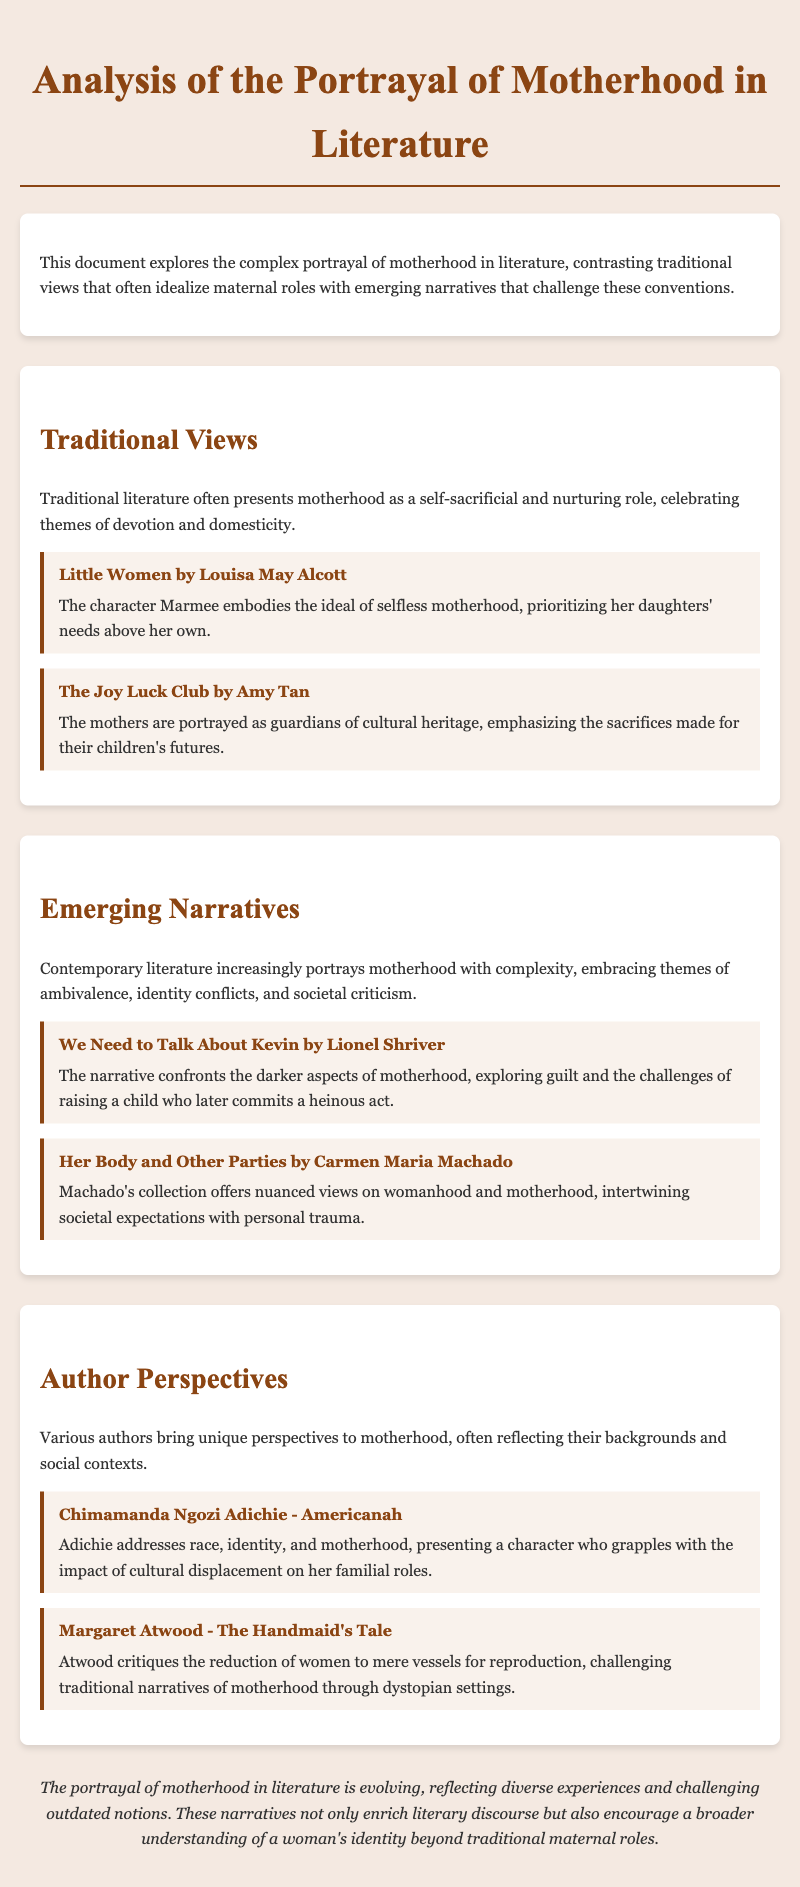What is the title of the document? The title is stated in the header of the document.
Answer: Analysis of the Portrayal of Motherhood in Literature Who wrote "Little Women"? The author of "Little Women" is mentioned in the examples section.
Answer: Louisa May Alcott What theme is explored in "We Need to Talk About Kevin"? The theme is specified in the description for "We Need to Talk About Kevin."
Answer: Guilt Which author critiques the reduction of women to mere vessels for reproduction? The author's name is noted in the author perspectives section.
Answer: Margaret Atwood What color is the background of the document? The background color can be found in the style section of the document.
Answer: #f4e9e1 How many examples are provided in the Traditional Views section? The number of examples is counted from the section statements.
Answer: 2 What literary device is prevalent in emerging narratives? This device is summarized in the Emerging Narratives section.
Answer: Ambivalence Which author addresses race and identity in their work? The author's perspective is discussed within the author perspectives section.
Answer: Chimamanda Ngozi Adichie What does the conclusion emphasize about motherhood in literature? The emphasis can be found in the conclusion text.
Answer: Evolving 